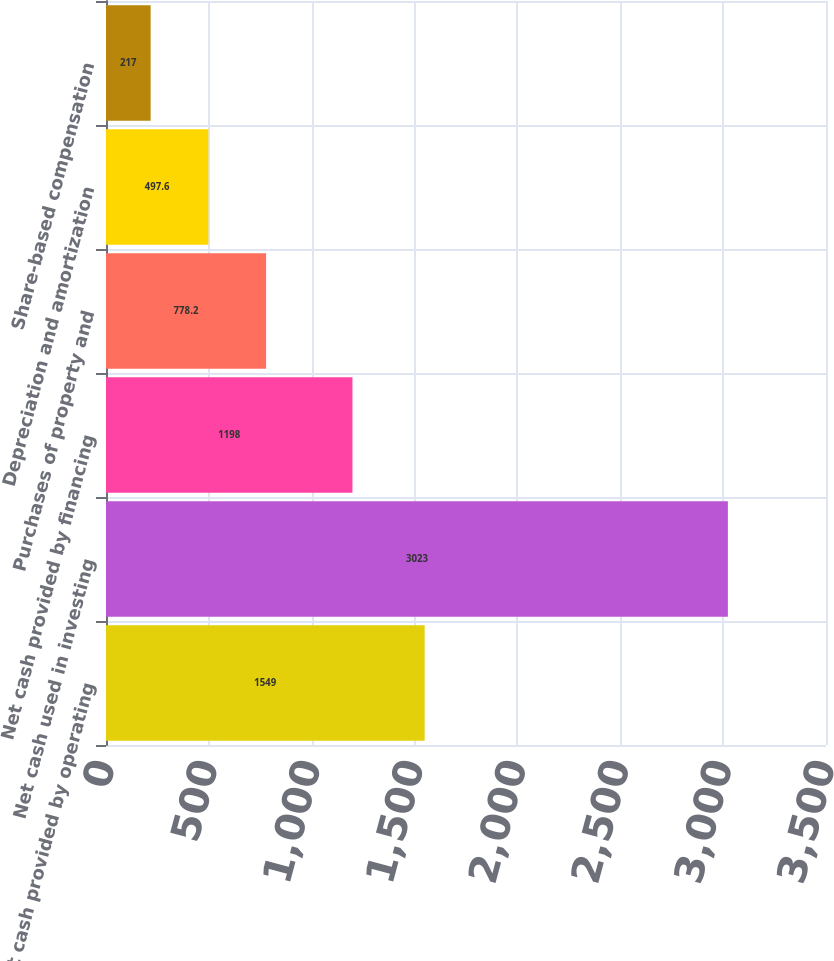Convert chart. <chart><loc_0><loc_0><loc_500><loc_500><bar_chart><fcel>Net cash provided by operating<fcel>Net cash used in investing<fcel>Net cash provided by financing<fcel>Purchases of property and<fcel>Depreciation and amortization<fcel>Share-based compensation<nl><fcel>1549<fcel>3023<fcel>1198<fcel>778.2<fcel>497.6<fcel>217<nl></chart> 